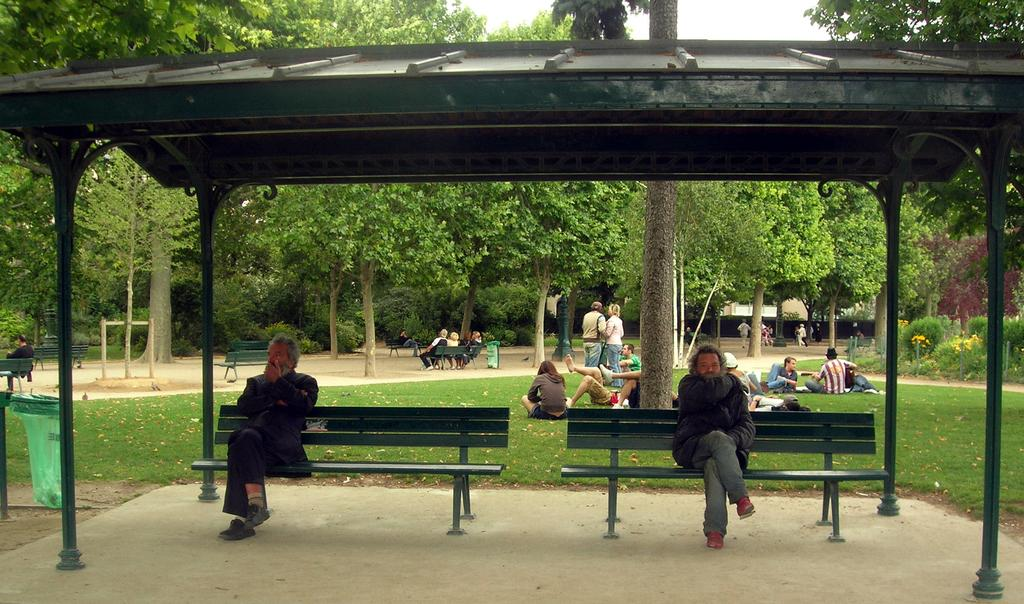How many people are sitting on benches in the image? There are two people sitting on benches in the image. What are some other activities people are doing in the image? There are people lying on the grass in the image. What type of vegetation can be seen in the image? There are trees visible in the image. What type of dirt can be seen on the skateboard in the image? There is no skateboard present in the image, so it is not possible to determine the type of dirt on it. 